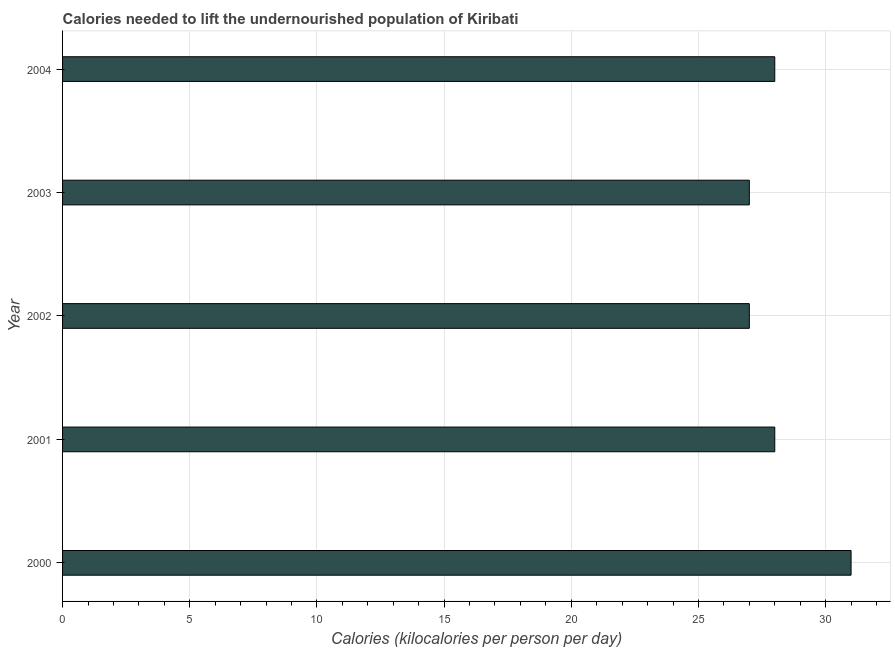What is the title of the graph?
Provide a short and direct response. Calories needed to lift the undernourished population of Kiribati. What is the label or title of the X-axis?
Your response must be concise. Calories (kilocalories per person per day). In which year was the depth of food deficit maximum?
Your response must be concise. 2000. In which year was the depth of food deficit minimum?
Keep it short and to the point. 2002. What is the sum of the depth of food deficit?
Give a very brief answer. 141. What is the average depth of food deficit per year?
Your response must be concise. 28. In how many years, is the depth of food deficit greater than 17 kilocalories?
Make the answer very short. 5. Do a majority of the years between 2000 and 2004 (inclusive) have depth of food deficit greater than 25 kilocalories?
Your answer should be very brief. Yes. Is the sum of the depth of food deficit in 2000 and 2002 greater than the maximum depth of food deficit across all years?
Keep it short and to the point. Yes. How many bars are there?
Provide a short and direct response. 5. Are all the bars in the graph horizontal?
Offer a very short reply. Yes. How many years are there in the graph?
Your answer should be very brief. 5. Are the values on the major ticks of X-axis written in scientific E-notation?
Ensure brevity in your answer.  No. What is the Calories (kilocalories per person per day) of 2000?
Your answer should be very brief. 31. What is the Calories (kilocalories per person per day) of 2001?
Keep it short and to the point. 28. What is the Calories (kilocalories per person per day) in 2002?
Offer a very short reply. 27. What is the Calories (kilocalories per person per day) of 2004?
Your answer should be compact. 28. What is the difference between the Calories (kilocalories per person per day) in 2000 and 2001?
Provide a succinct answer. 3. What is the difference between the Calories (kilocalories per person per day) in 2000 and 2002?
Give a very brief answer. 4. What is the difference between the Calories (kilocalories per person per day) in 2001 and 2003?
Your response must be concise. 1. What is the difference between the Calories (kilocalories per person per day) in 2001 and 2004?
Provide a succinct answer. 0. What is the difference between the Calories (kilocalories per person per day) in 2002 and 2003?
Give a very brief answer. 0. What is the difference between the Calories (kilocalories per person per day) in 2002 and 2004?
Provide a succinct answer. -1. What is the ratio of the Calories (kilocalories per person per day) in 2000 to that in 2001?
Your response must be concise. 1.11. What is the ratio of the Calories (kilocalories per person per day) in 2000 to that in 2002?
Provide a short and direct response. 1.15. What is the ratio of the Calories (kilocalories per person per day) in 2000 to that in 2003?
Ensure brevity in your answer.  1.15. What is the ratio of the Calories (kilocalories per person per day) in 2000 to that in 2004?
Make the answer very short. 1.11. What is the ratio of the Calories (kilocalories per person per day) in 2001 to that in 2002?
Your answer should be very brief. 1.04. What is the ratio of the Calories (kilocalories per person per day) in 2001 to that in 2003?
Make the answer very short. 1.04. What is the ratio of the Calories (kilocalories per person per day) in 2002 to that in 2003?
Your answer should be compact. 1. What is the ratio of the Calories (kilocalories per person per day) in 2003 to that in 2004?
Your response must be concise. 0.96. 